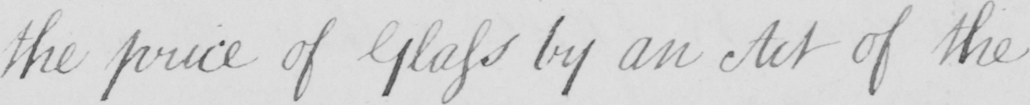Transcribe the text shown in this historical manuscript line. the price of Glass by an Act of the 